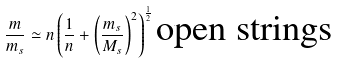Convert formula to latex. <formula><loc_0><loc_0><loc_500><loc_500>\frac { m } { m _ { s } } \simeq n \left ( \frac { 1 } { n } + \left ( \frac { m _ { s } } { M _ { s } } \right ) ^ { 2 } \right ) ^ { \frac { 1 } { 2 } } \text {open strings}</formula> 